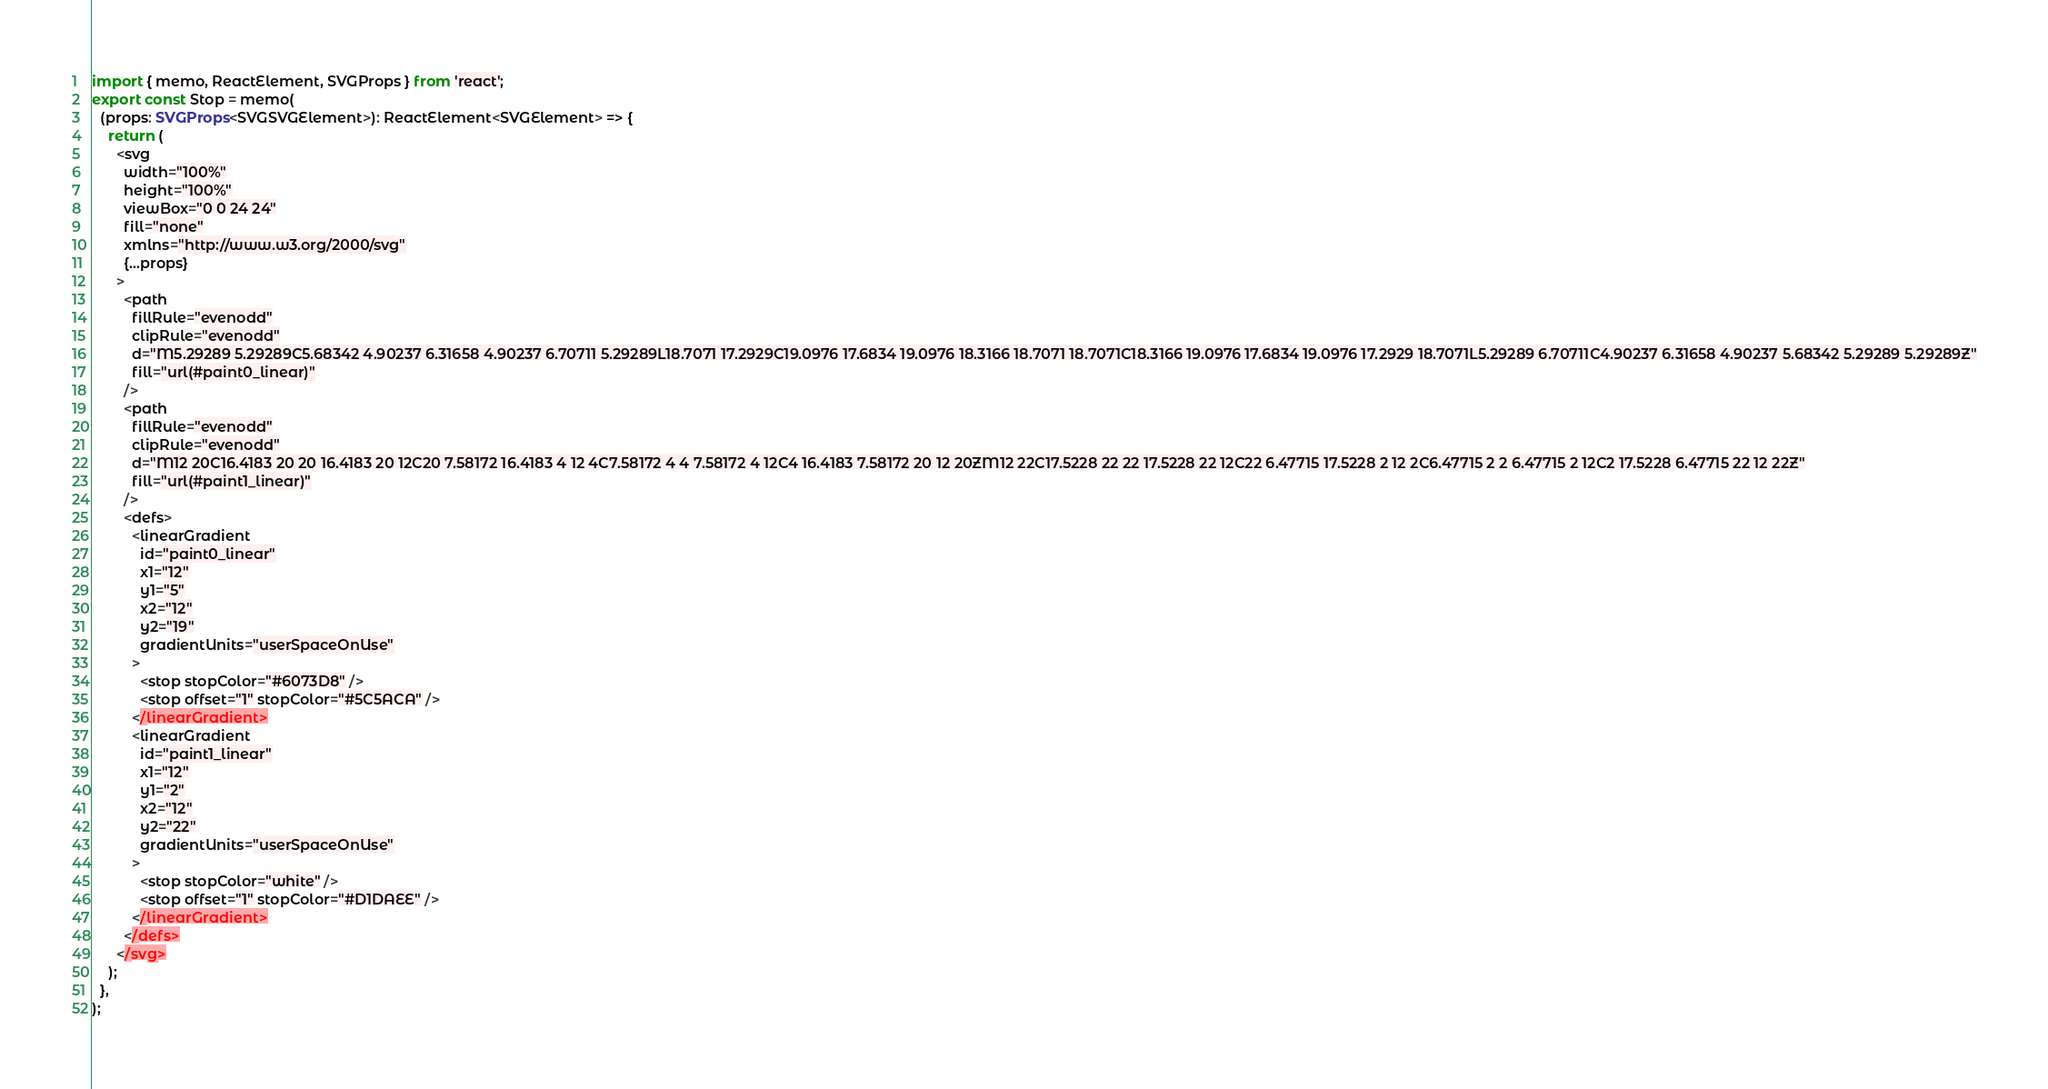<code> <loc_0><loc_0><loc_500><loc_500><_TypeScript_>import { memo, ReactElement, SVGProps } from 'react';
export const Stop = memo(
  (props: SVGProps<SVGSVGElement>): ReactElement<SVGElement> => {
    return (
      <svg
        width="100%"
        height="100%"
        viewBox="0 0 24 24"
        fill="none"
        xmlns="http://www.w3.org/2000/svg"
        {...props}
      >
        <path
          fillRule="evenodd"
          clipRule="evenodd"
          d="M5.29289 5.29289C5.68342 4.90237 6.31658 4.90237 6.70711 5.29289L18.7071 17.2929C19.0976 17.6834 19.0976 18.3166 18.7071 18.7071C18.3166 19.0976 17.6834 19.0976 17.2929 18.7071L5.29289 6.70711C4.90237 6.31658 4.90237 5.68342 5.29289 5.29289Z"
          fill="url(#paint0_linear)"
        />
        <path
          fillRule="evenodd"
          clipRule="evenodd"
          d="M12 20C16.4183 20 20 16.4183 20 12C20 7.58172 16.4183 4 12 4C7.58172 4 4 7.58172 4 12C4 16.4183 7.58172 20 12 20ZM12 22C17.5228 22 22 17.5228 22 12C22 6.47715 17.5228 2 12 2C6.47715 2 2 6.47715 2 12C2 17.5228 6.47715 22 12 22Z"
          fill="url(#paint1_linear)"
        />
        <defs>
          <linearGradient
            id="paint0_linear"
            x1="12"
            y1="5"
            x2="12"
            y2="19"
            gradientUnits="userSpaceOnUse"
          >
            <stop stopColor="#6073D8" />
            <stop offset="1" stopColor="#5C5ACA" />
          </linearGradient>
          <linearGradient
            id="paint1_linear"
            x1="12"
            y1="2"
            x2="12"
            y2="22"
            gradientUnits="userSpaceOnUse"
          >
            <stop stopColor="white" />
            <stop offset="1" stopColor="#D1DAEE" />
          </linearGradient>
        </defs>
      </svg>
    );
  },
);
</code> 